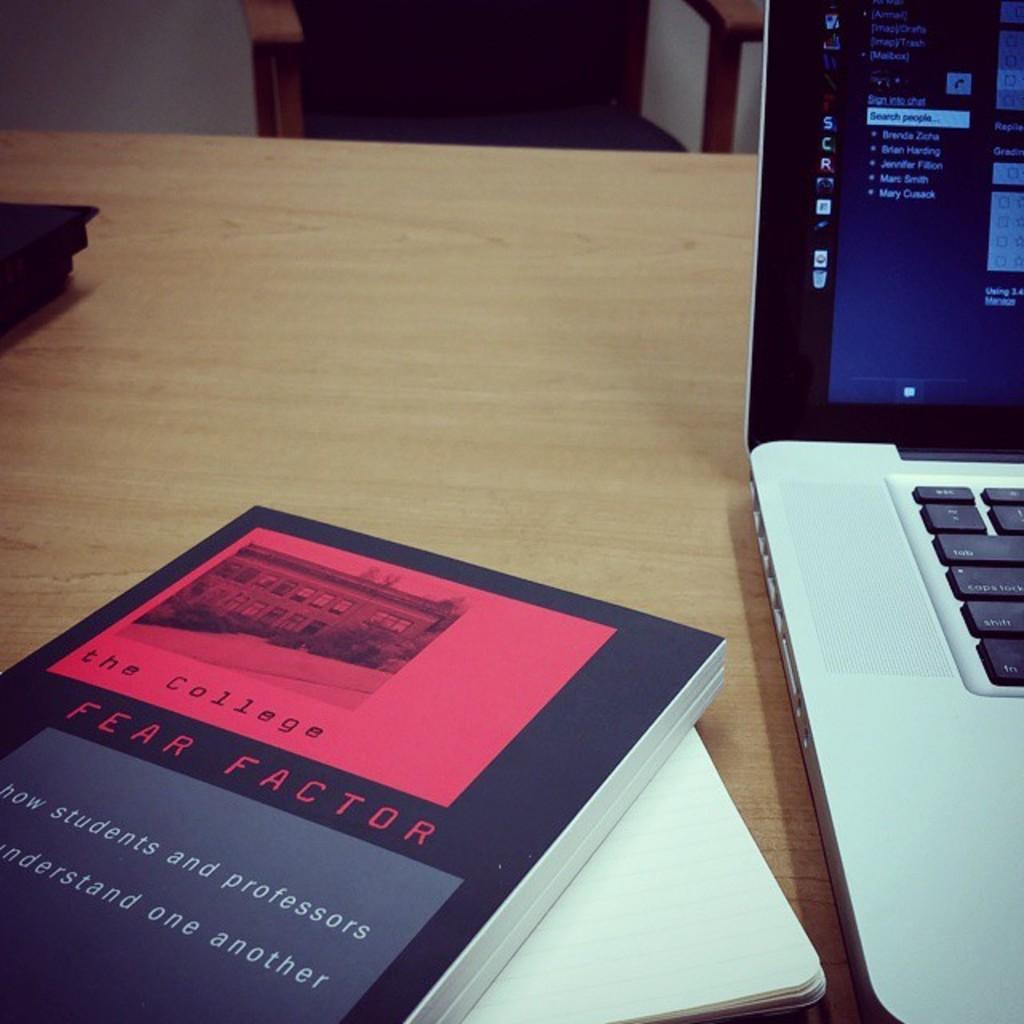<image>
Create a compact narrative representing the image presented. A book titled The College Fear Factor sits on a table. 